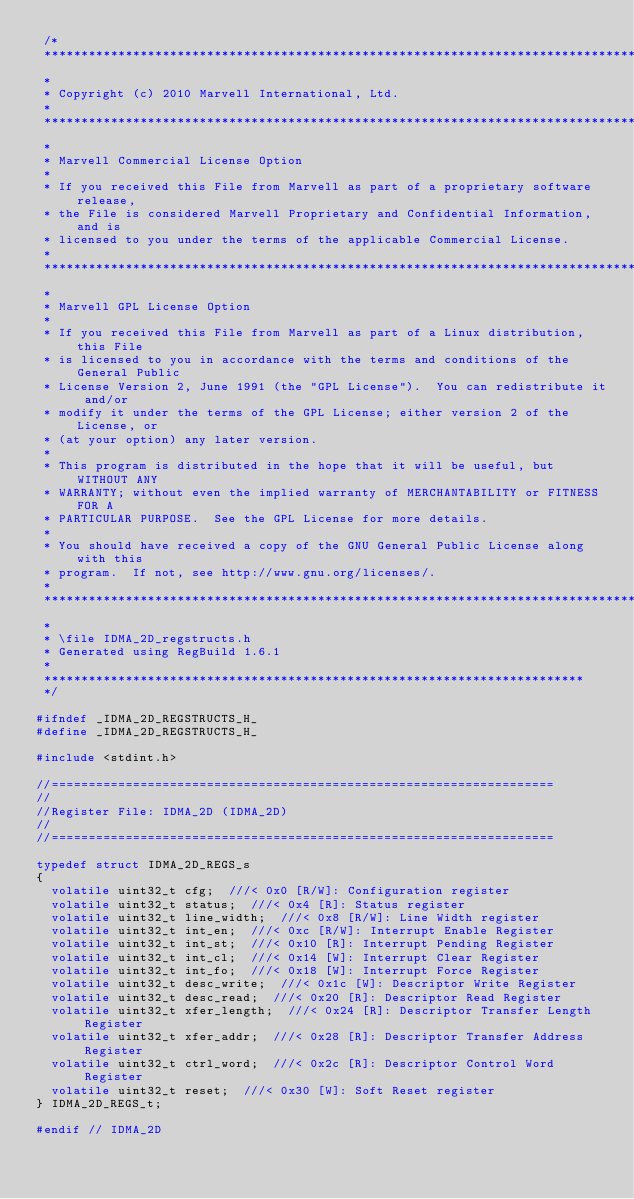<code> <loc_0><loc_0><loc_500><loc_500><_C_> /*
 **************************************************************************************
 *
 * Copyright (c) 2010 Marvell International, Ltd.
 *
 **************************************************************************************
 *
 * Marvell Commercial License Option
 *
 * If you received this File from Marvell as part of a proprietary software release,
 * the File is considered Marvell Proprietary and Confidential Information, and is
 * licensed to you under the terms of the applicable Commercial License.
 *
 **************************************************************************************
 *
 * Marvell GPL License Option
 *
 * If you received this File from Marvell as part of a Linux distribution, this File
 * is licensed to you in accordance with the terms and conditions of the General Public
 * License Version 2, June 1991 (the "GPL License").  You can redistribute it and/or
 * modify it under the terms of the GPL License; either version 2 of the License, or
 * (at your option) any later version.
 *
 * This program is distributed in the hope that it will be useful, but WITHOUT ANY
 * WARRANTY; without even the implied warranty of MERCHANTABILITY or FITNESS FOR A
 * PARTICULAR PURPOSE.  See the GPL License for more details.
 *
 * You should have received a copy of the GNU General Public License along with this
 * program.  If not, see http://www.gnu.org/licenses/.
 *
 **************************************************************************************
 *
 * \file IDMA_2D_regstructs.h
 * Generated using RegBuild 1.6.1
 *
 *************************************************************************
 */

#ifndef _IDMA_2D_REGSTRUCTS_H_
#define _IDMA_2D_REGSTRUCTS_H_

#include <stdint.h>

//====================================================================
//
//Register File: IDMA_2D (IDMA_2D)
//
//====================================================================

typedef struct IDMA_2D_REGS_s
{
  volatile uint32_t cfg;  ///< 0x0 [R/W]: Configuration register
  volatile uint32_t status;  ///< 0x4 [R]: Status register
  volatile uint32_t line_width;  ///< 0x8 [R/W]: Line Width register
  volatile uint32_t int_en;  ///< 0xc [R/W]: Interrupt Enable Register
  volatile uint32_t int_st;  ///< 0x10 [R]: Interrupt Pending Register
  volatile uint32_t int_cl;  ///< 0x14 [W]: Interrupt Clear Register
  volatile uint32_t int_fo;  ///< 0x18 [W]: Interrupt Force Register
  volatile uint32_t desc_write;  ///< 0x1c [W]: Descriptor Write Register
  volatile uint32_t desc_read;  ///< 0x20 [R]: Descriptor Read Register
  volatile uint32_t xfer_length;  ///< 0x24 [R]: Descriptor Transfer Length Register
  volatile uint32_t xfer_addr;  ///< 0x28 [R]: Descriptor Transfer Address Register
  volatile uint32_t ctrl_word;  ///< 0x2c [R]: Descriptor Control Word Register
  volatile uint32_t reset;  ///< 0x30 [W]: Soft Reset register
} IDMA_2D_REGS_t;

#endif // IDMA_2D
</code> 